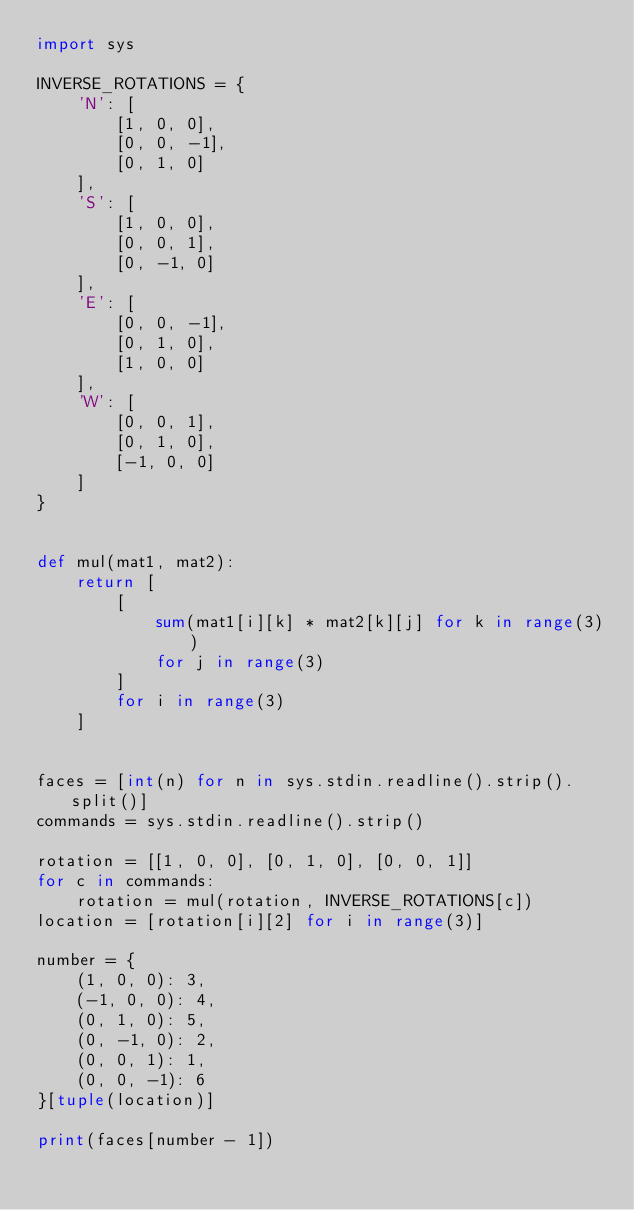Convert code to text. <code><loc_0><loc_0><loc_500><loc_500><_Python_>import sys

INVERSE_ROTATIONS = {
    'N': [
        [1, 0, 0],
        [0, 0, -1],
        [0, 1, 0]
    ],
    'S': [
        [1, 0, 0],
        [0, 0, 1],
        [0, -1, 0]
    ],
    'E': [
        [0, 0, -1],
        [0, 1, 0],
        [1, 0, 0]
    ],
    'W': [
        [0, 0, 1],
        [0, 1, 0],
        [-1, 0, 0]
    ]
}


def mul(mat1, mat2):
    return [
        [
            sum(mat1[i][k] * mat2[k][j] for k in range(3))
            for j in range(3)
        ]
        for i in range(3)
    ]


faces = [int(n) for n in sys.stdin.readline().strip().split()]
commands = sys.stdin.readline().strip()

rotation = [[1, 0, 0], [0, 1, 0], [0, 0, 1]]
for c in commands:
    rotation = mul(rotation, INVERSE_ROTATIONS[c])
location = [rotation[i][2] for i in range(3)]

number = {
    (1, 0, 0): 3,
    (-1, 0, 0): 4,
    (0, 1, 0): 5,
    (0, -1, 0): 2,
    (0, 0, 1): 1,
    (0, 0, -1): 6
}[tuple(location)]

print(faces[number - 1])

</code> 